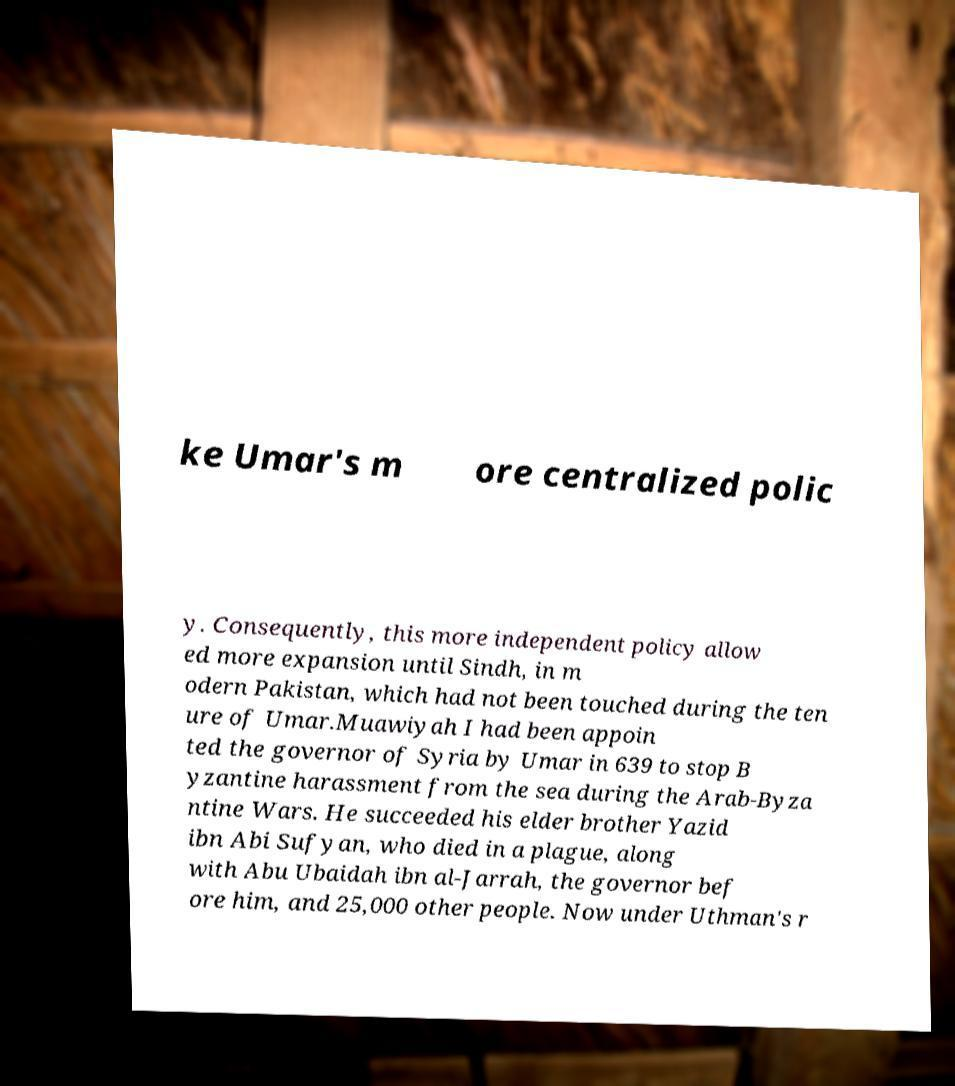What messages or text are displayed in this image? I need them in a readable, typed format. ke Umar's m ore centralized polic y. Consequently, this more independent policy allow ed more expansion until Sindh, in m odern Pakistan, which had not been touched during the ten ure of Umar.Muawiyah I had been appoin ted the governor of Syria by Umar in 639 to stop B yzantine harassment from the sea during the Arab-Byza ntine Wars. He succeeded his elder brother Yazid ibn Abi Sufyan, who died in a plague, along with Abu Ubaidah ibn al-Jarrah, the governor bef ore him, and 25,000 other people. Now under Uthman's r 